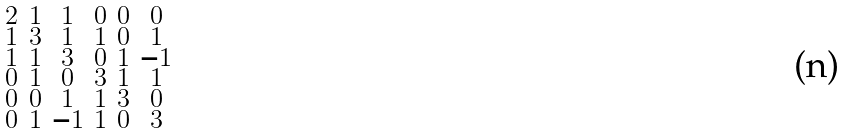<formula> <loc_0><loc_0><loc_500><loc_500>\begin{smallmatrix} 2 & 1 & 1 & 0 & 0 & 0 \\ 1 & 3 & 1 & 1 & 0 & 1 \\ 1 & 1 & 3 & 0 & 1 & - 1 \\ 0 & 1 & 0 & 3 & 1 & 1 \\ 0 & 0 & 1 & 1 & 3 & 0 \\ 0 & 1 & - 1 & 1 & 0 & 3 \end{smallmatrix}</formula> 